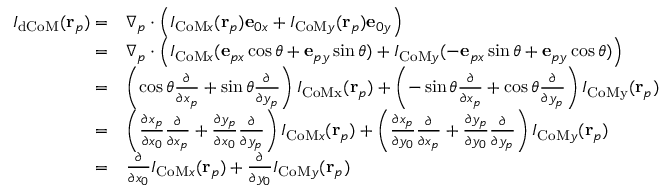Convert formula to latex. <formula><loc_0><loc_0><loc_500><loc_500>\begin{array} { r l } { I _ { d C o M } ( r _ { p } ) = } & { \nabla _ { p } \cdot \left ( I _ { C o M x } ( r _ { p } ) e _ { 0 x } + I _ { C o M y } ( r _ { p } ) e _ { 0 y } \right ) } \\ { = } & { \nabla _ { p } \cdot \left ( I _ { C o M x } ( e _ { p x } \cos \theta + e _ { p y } \sin \theta ) + I _ { C o M y } ( - e _ { p x } \sin \theta + e _ { p y } \cos \theta ) \right ) } \\ { = } & { \left ( \cos \theta \frac { \partial } { \partial x _ { p } } + \sin \theta \frac { \partial } { \partial y _ { p } } \right ) I _ { C o M x } ( r _ { p } ) + \left ( - \sin \theta \frac { \partial } { \partial x _ { p } } + \cos \theta \frac { \partial } { \partial y _ { p } } \right ) I _ { C o M y } ( r _ { p } ) } \\ { = } & { \left ( \frac { \partial x _ { p } } { \partial x _ { 0 } } \frac { \partial } { \partial x _ { p } } + \frac { \partial y _ { p } } { \partial x _ { 0 } } \frac { \partial } { \partial y _ { p } } \right ) I _ { C o M x } ( r _ { p } ) + \left ( \frac { \partial x _ { p } } { \partial y _ { 0 } } \frac { \partial } { \partial x _ { p } } + \frac { \partial y _ { p } } { \partial y _ { 0 } } \frac { \partial } { \partial y _ { p } } \right ) I _ { C o M y } ( r _ { p } ) } \\ { = } & { \frac { \partial } { \partial x _ { 0 } } I _ { C o M x } ( r _ { p } ) + \frac { \partial } { \partial y _ { 0 } } I _ { C o M y } ( r _ { p } ) } \end{array}</formula> 